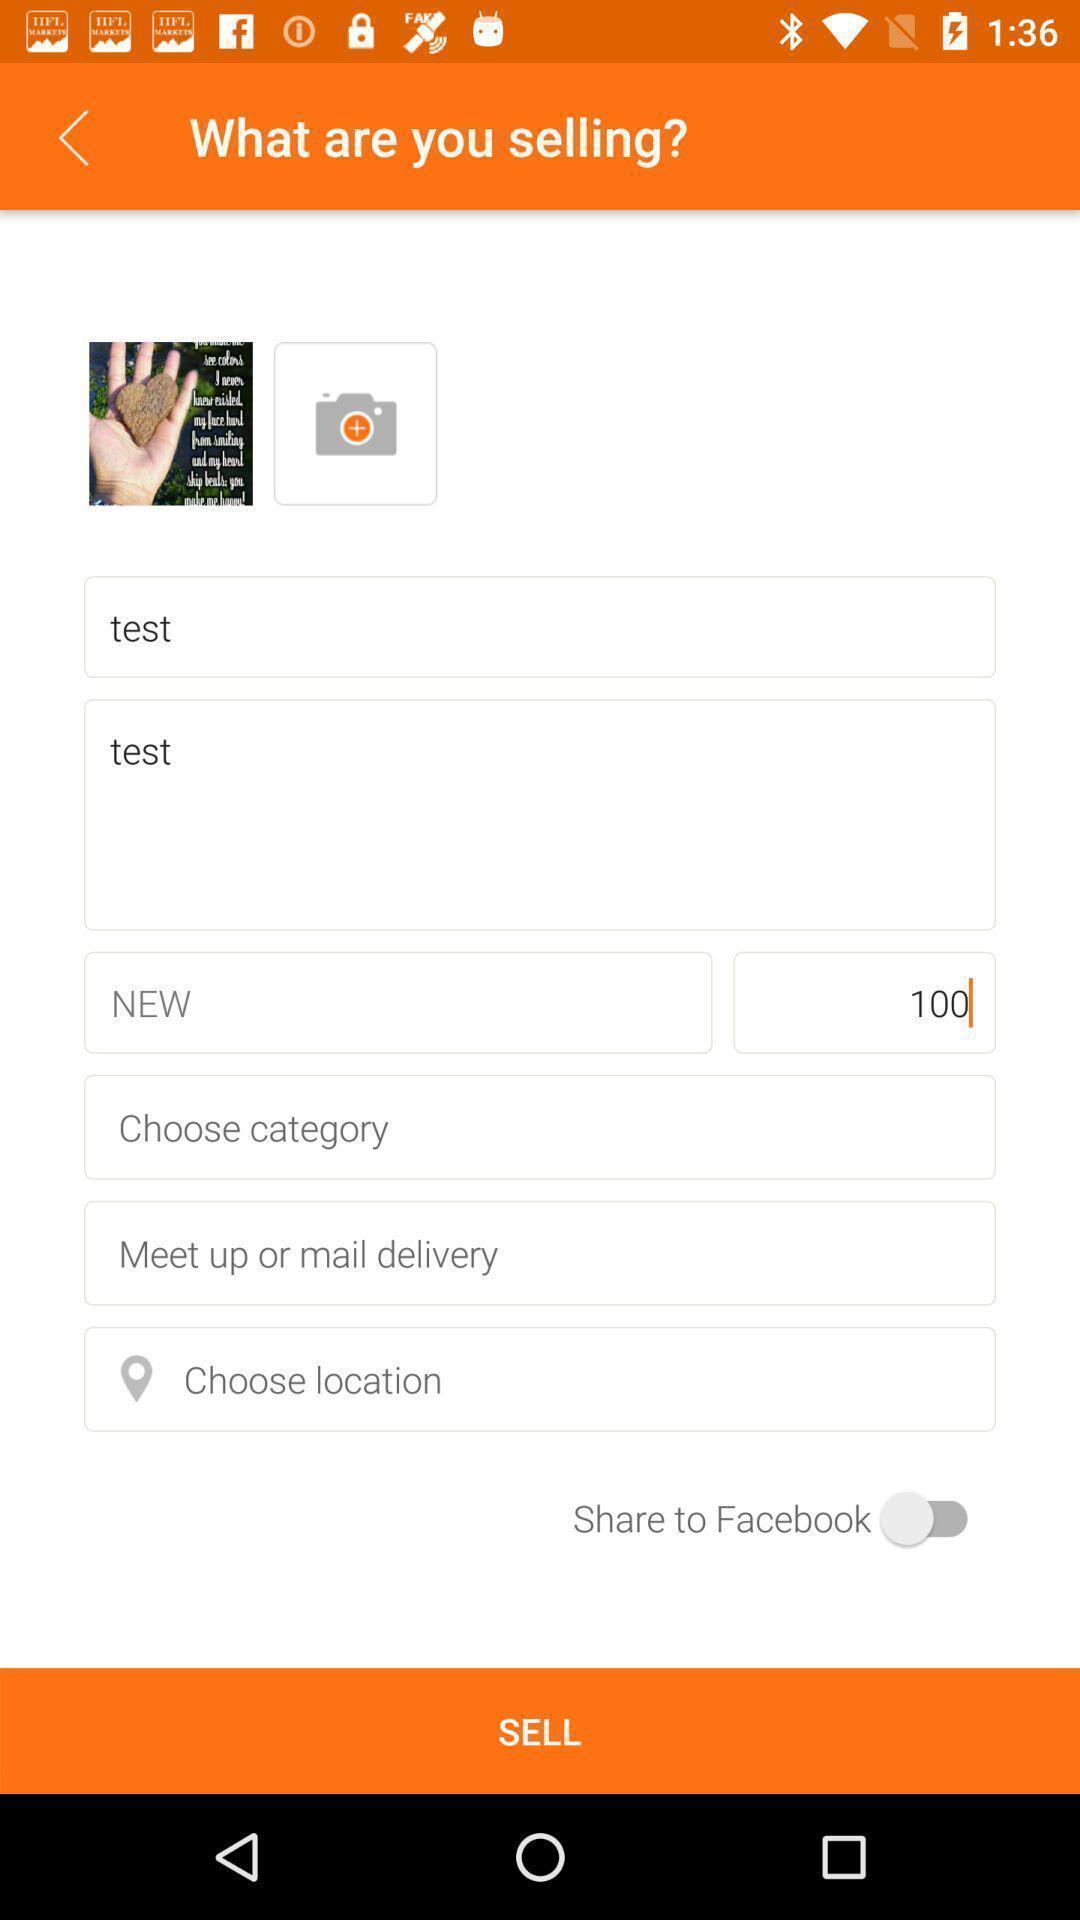Provide a detailed account of this screenshot. Shopping app displayed selling page. 